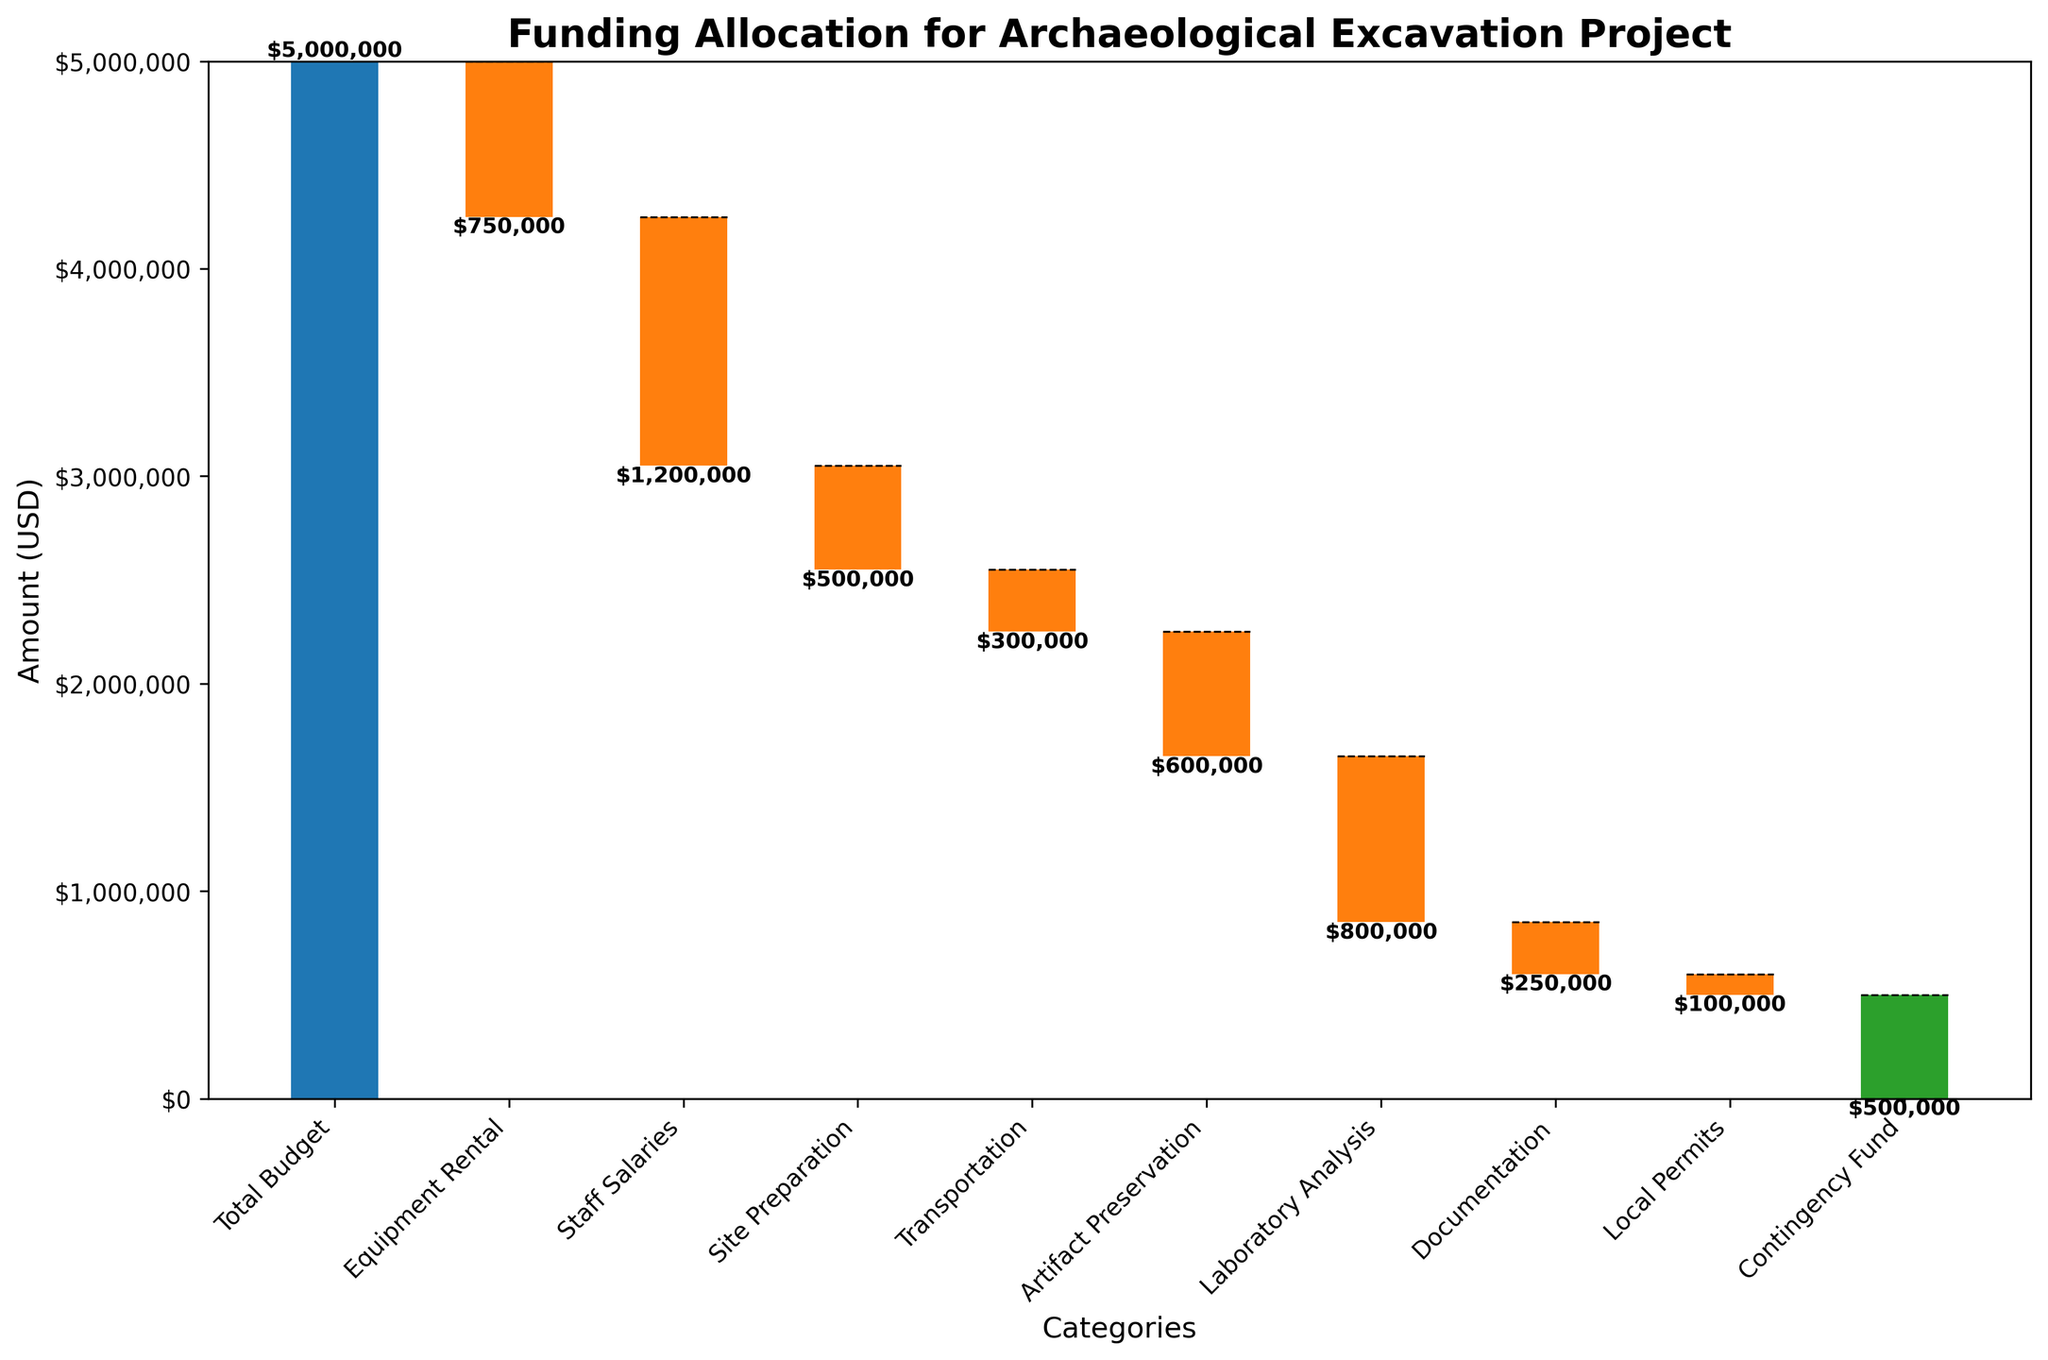What is the title of the figure? The title is displayed at the top of the chart.
Answer: Funding Allocation for Archaeological Excavation Project What is the initial total budget for the project? The initial total budget is represented by the first bar in the waterfall chart.
Answer: $5,000,000 How much is allocated for Equipment Rental? Look for the bar labeled 'Equipment Rental' and read its value.
Answer: $750,000 Which category has the smallest absolute amount allocated? Compare the height of each bar to determine which has the smallest value.
Answer: Local Permits What is the total amount allocated to Staff Salaries and Laboratory Analysis combined? Sum the values of 'Staff Salaries' and 'Laboratory Analysis': $1,200,000 + $800,000 = $2,000,000.
Answer: $2,000,000 How does the allocation for Artifact Preservation compare to that for Site Preparation? Compare the height of the bars labeled 'Artifact Preservation' and 'Site Preparation'.
Answer: Artifact Preservation: $600,000, Site Preparation: $500,000, Artifact Preservation is more What is the cumulative remaining budget after Equipment Rental and Staff Salaries allocations? Subtract 'Equipment Rental' and 'Staff Salaries' from the total budget: $5,000,000 - $750,000 - $1,200,000 = $3,050,000.
Answer: $3,050,000 Which category has the highest expenditure? Identify the bar with the largest negative value.
Answer: Staff Salaries How much is the contingency fund? Look for the bar labeled 'Contingency Fund' and read its value.
Answer: $500,000 What is the final remaining budget after all allocations? The final remaining budget is represented by the last bar at the right of the chart, which accumulates all reductions.
Answer: $0 